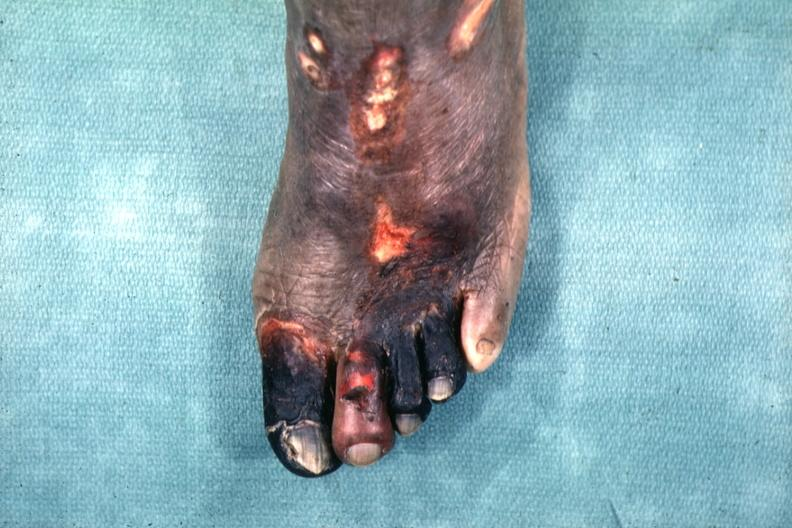re feet present?
Answer the question using a single word or phrase. No 